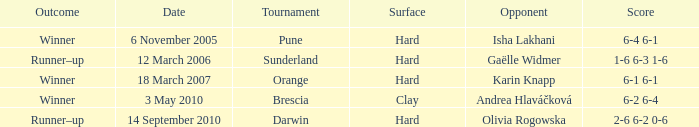What was the date of the orange tournament? 18 March 2007. 